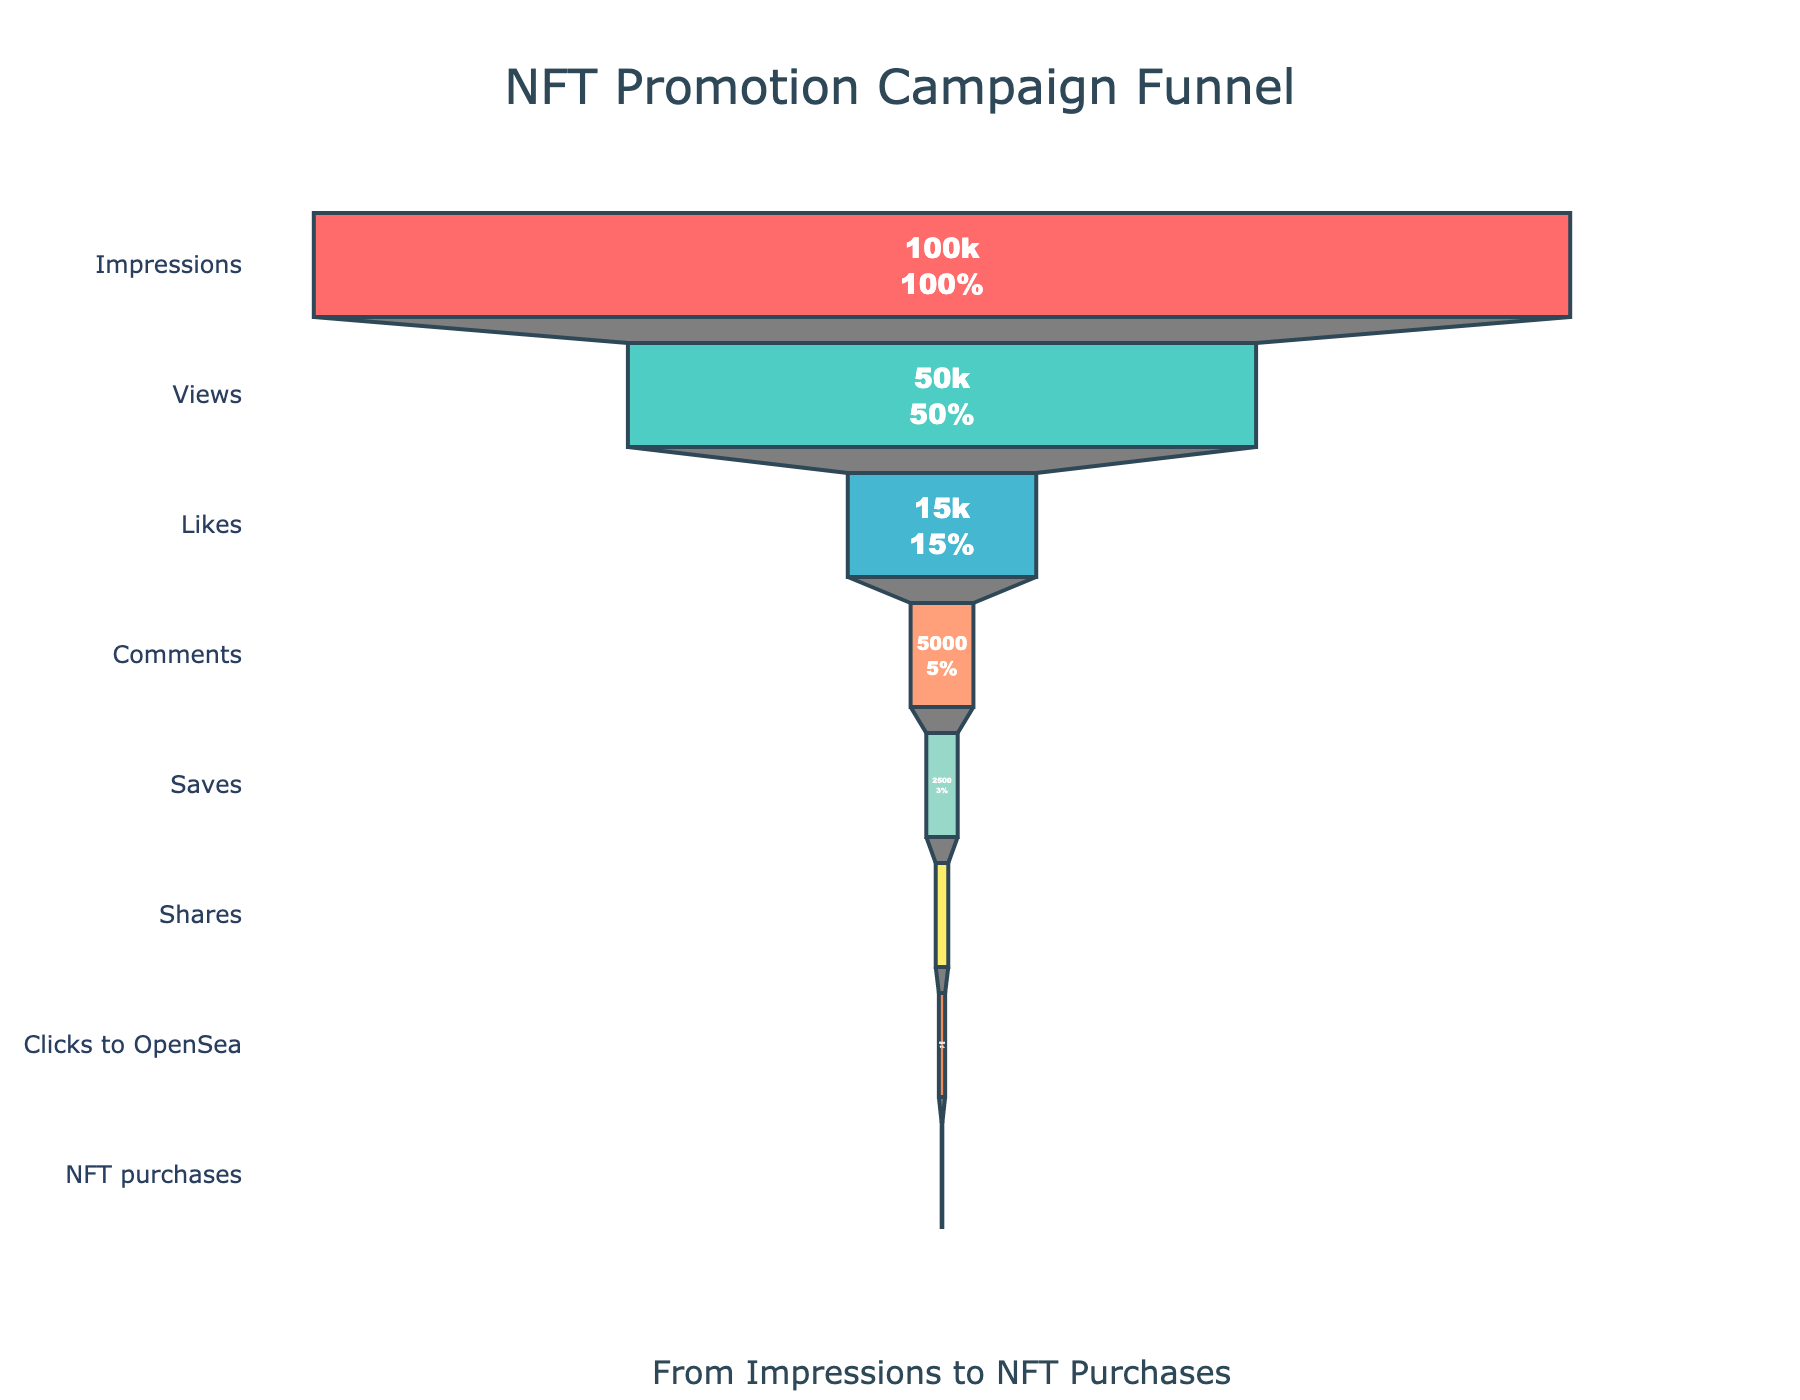What is the title of the funnel chart? The title is located at the top of the chart and provides a summary of the chart's purpose. It reads "NFT Promotion Campaign Funnel".
Answer: NFT Promotion Campaign Funnel What is the percentage of Impressions that resulted in Views? The funnel chart shows both absolute values and percentages at each stage. To find this percentage, locate the "Views" stage and check its percentage relative to the initial "Impressions". The text shows this percentage directly.
Answer: 50% How many stages are there in the funnel chart? To determine the number of stages, count the number of distinct sections in the funnel. Each stage represents a different step in the promotion campaign.
Answer: 8 Which stage has the lowest count? The funnel chart indicates the count for each stage in terms of heights. The stage with the smallest height has the lowest count, and it is "NFT purchases".
Answer: NFT purchases What is the total amount of decrease in count from Saves to Shares? To find the decrease in count, subtract the count at the "Shares" stage from the count at the "Saves" stage. The counts are respectively 2500 and 1000.
Answer: 1500 Which two stages show the steepest drop-off in the funnel chart? To identify steep drop-offs, examine where the funnel narrows significantly, indicating a large decrease in count between consecutive stages. Here, the drop-off from "Views" to "Likes" and from "Clicks to OpenSea" to "NFT purchases" are particularly steep.
Answer: Views to Likes and Clicks to OpenSea to NFT purchases What is the ratio of Comments to Likes? The counts for Comments and Likes can be found in their respective stages. Calculate the ratio of Comments (5000) to Likes (15000) by dividing the count of Comments by the count of Likes.
Answer: 1:3 At which stage do we see the highest percentage drop relative to the previous stage? Calculate the percentage drop for each stage relative to the previous stage by taking (Previous Stage Count - Current Stage Count) / Previous Stage Count * 100. The "NFT purchases" stage displays the highest percentage drop relative to "Clicks to OpenSea".
Answer: NFT purchases What percentage of total Impressions resulted in NFT Purchases? Locate the "NFT purchases" stage and check its percentage relative to the total initial "Impressions". The chart shows this percentage directly, which is the fraction of the initial Impressions that resulted in NFT purchases.
Answer: 0.05% How many more people liked than commented on the posts? To find this difference, subtract the count at the "Comments" stage from the count at the "Likes" stage. The values are respectively 15000 (Likes) and 5000 (Comments).
Answer: 10000 